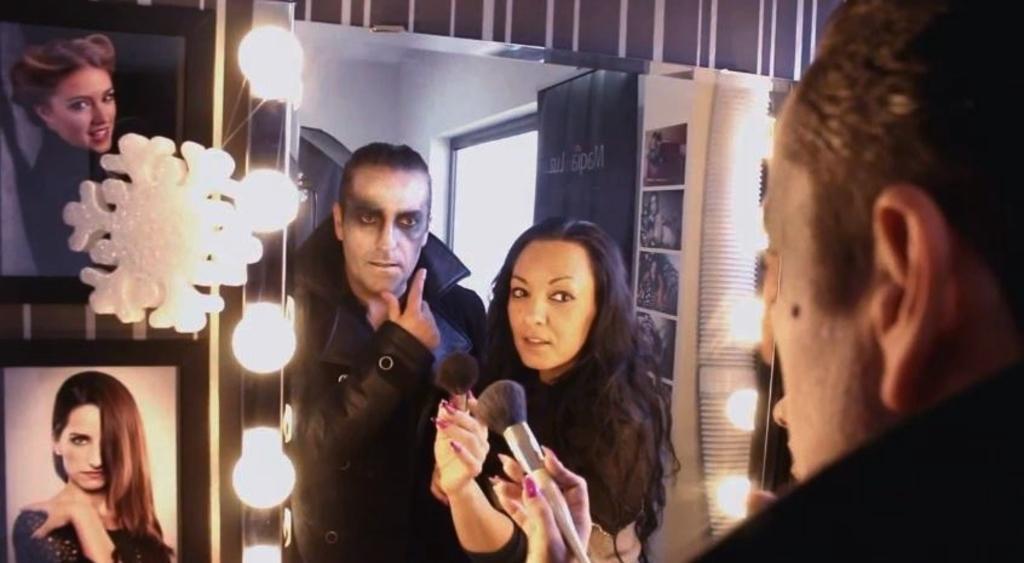In one or two sentences, can you explain what this image depicts? In this image I can see two persons standing, the person at left is wearing black color dress and holding a brush. Background I can see few lights, windows and the wall is in white color and I can also see few frames. 